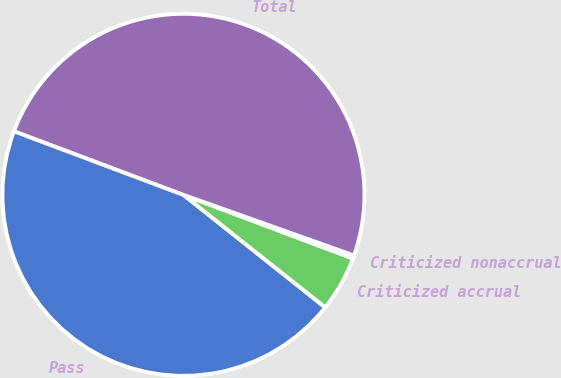Convert chart. <chart><loc_0><loc_0><loc_500><loc_500><pie_chart><fcel>Pass<fcel>Criticized accrual<fcel>Criticized nonaccrual<fcel>Total<nl><fcel>45.04%<fcel>4.96%<fcel>0.28%<fcel>49.72%<nl></chart> 